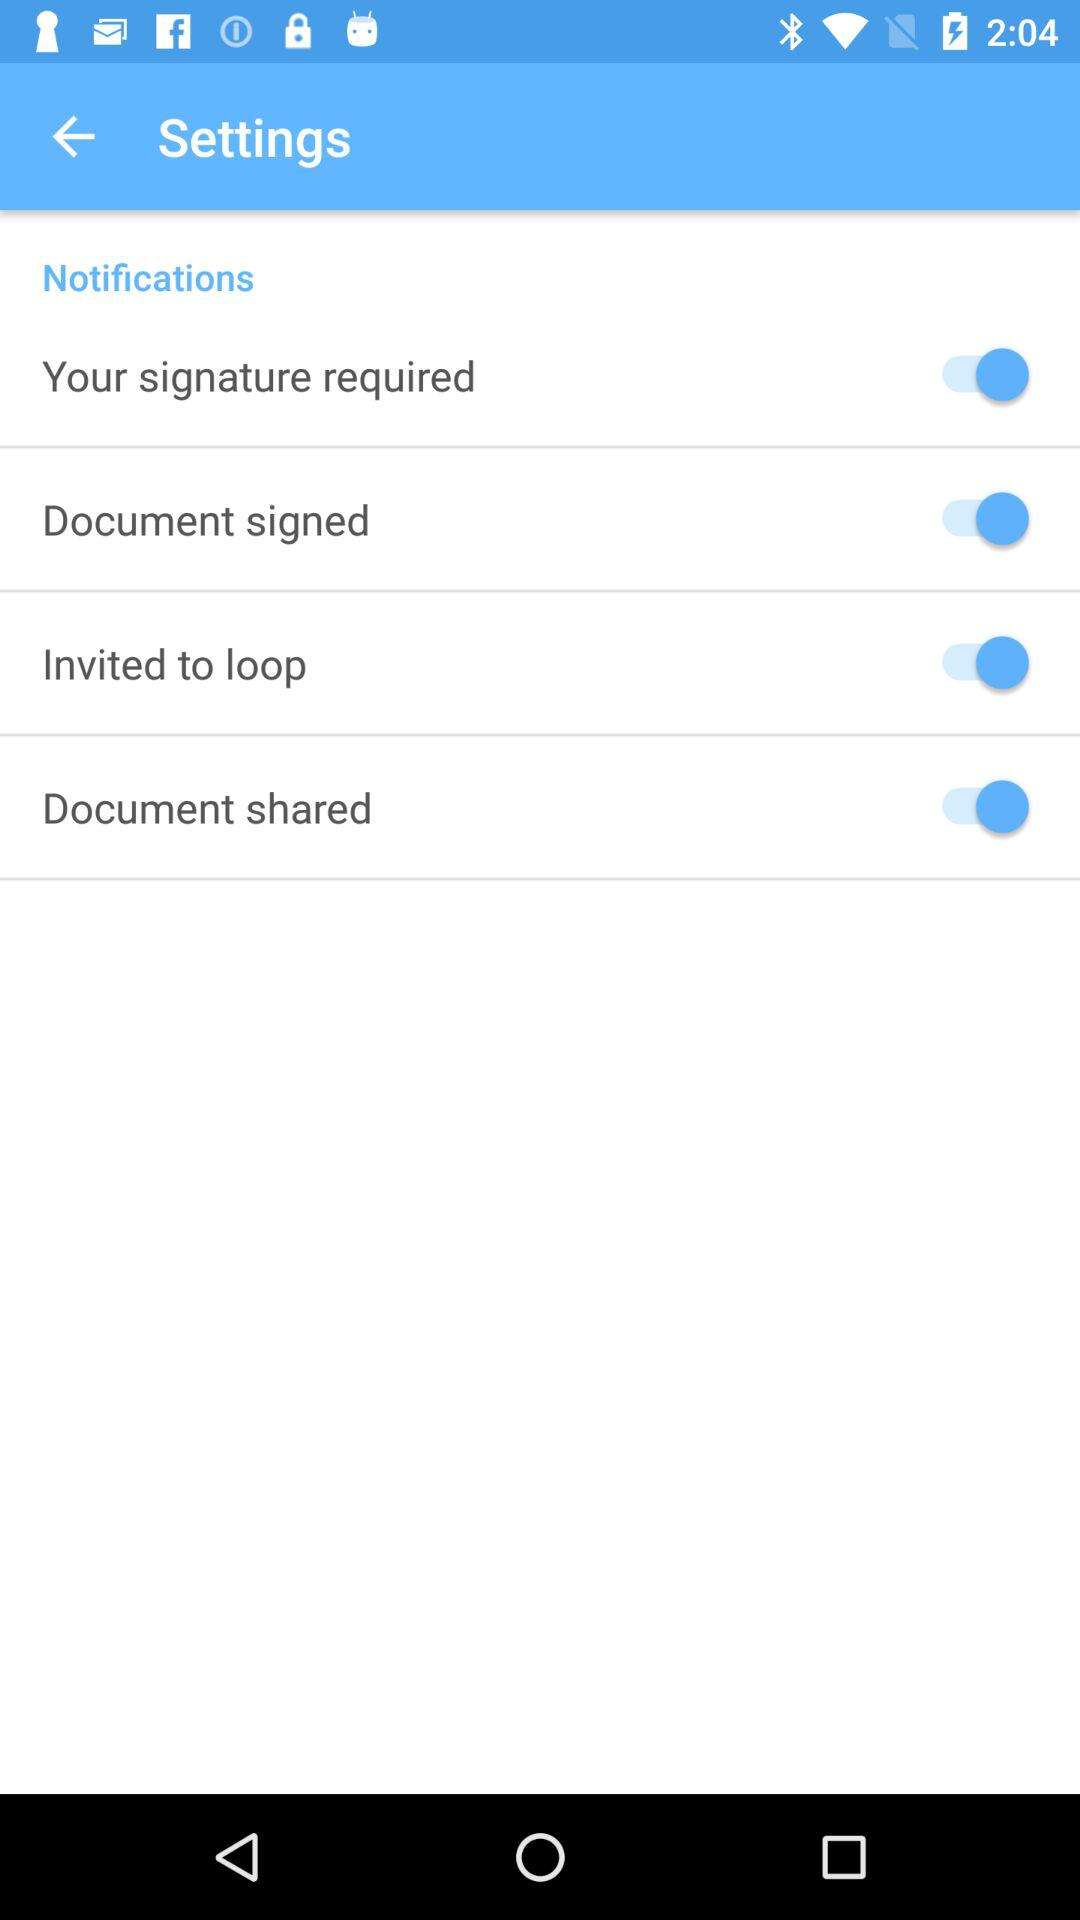Is the status of "Document signed" switch on or off? The status is "on". 